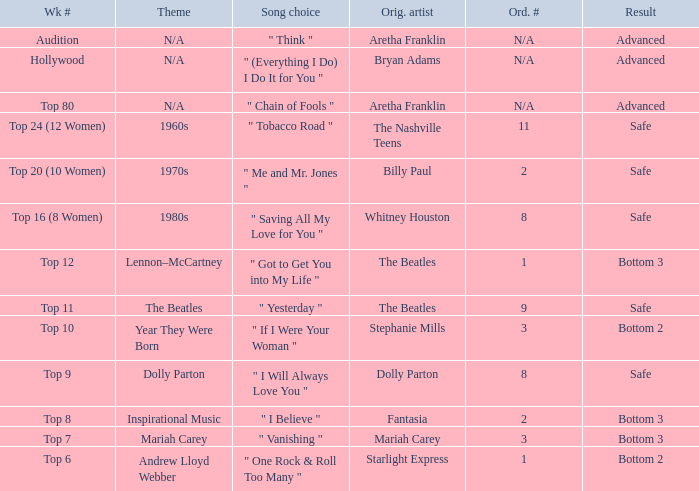Name the song choice when week number is hollywood " (Everything I Do) I Do It for You ". 